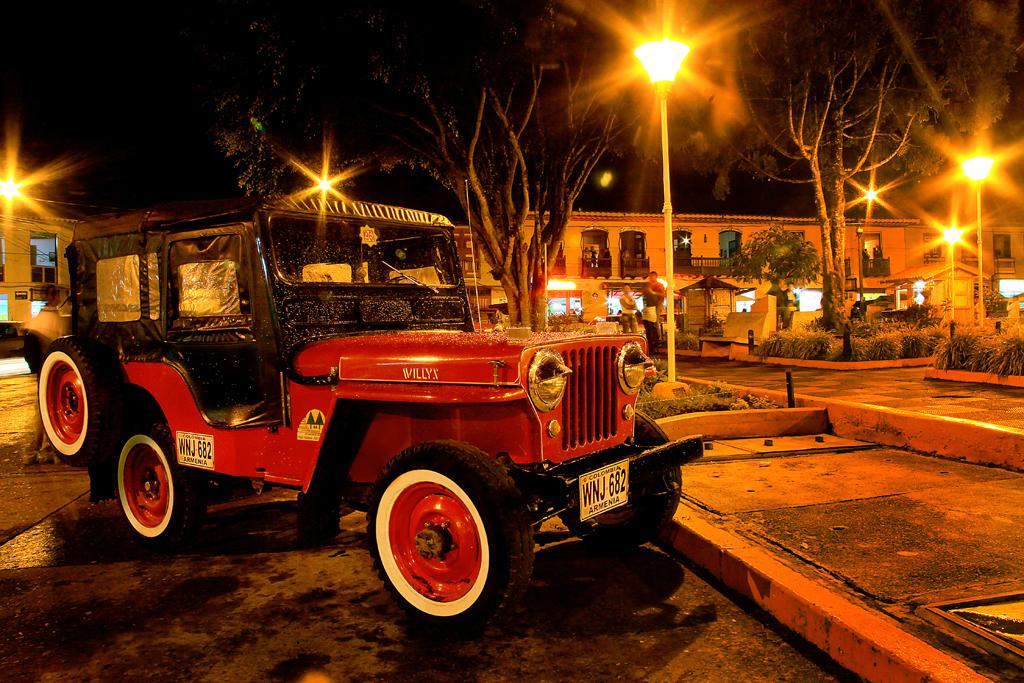What vehicle is present in the image? There is a jeep in the image. What can be seen in the background of the image? In the background of the image, there are poles, lights, trees, buildings, and a group of people. Can you describe the environment in the background of the image? The background of the image features a mix of natural and urban elements, including trees, buildings, and poles with lights. What type of note is being passed between the trees in the image? There is no note present in the image; it features a jeep and various background elements. 